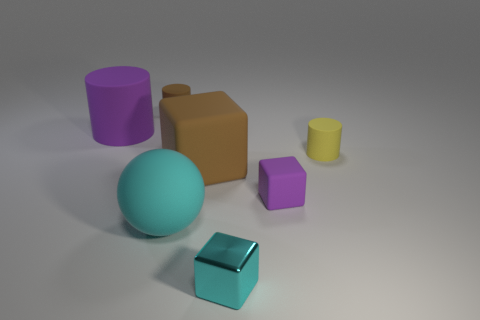Add 1 big gray rubber cubes. How many objects exist? 8 Subtract all cylinders. How many objects are left? 4 Subtract all large gray metallic blocks. Subtract all big cyan rubber things. How many objects are left? 6 Add 5 spheres. How many spheres are left? 6 Add 2 large blue balls. How many large blue balls exist? 2 Subtract 1 cyan spheres. How many objects are left? 6 